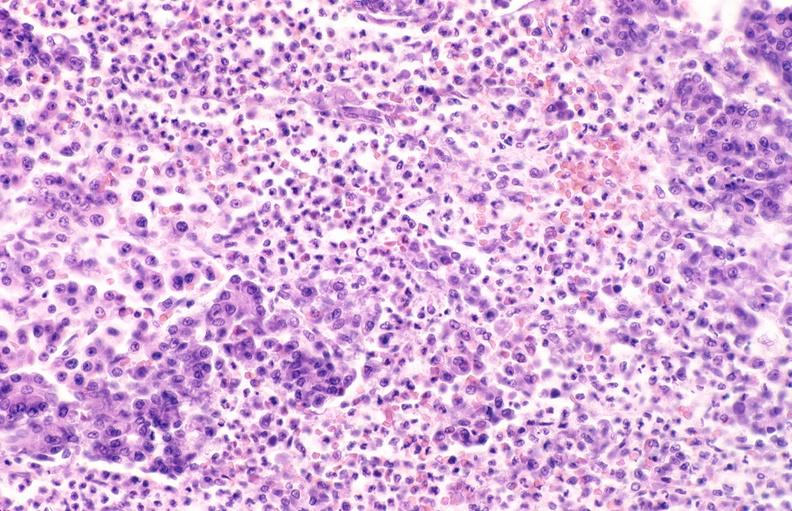where is this?
Answer the question using a single word or phrase. Pancreas 